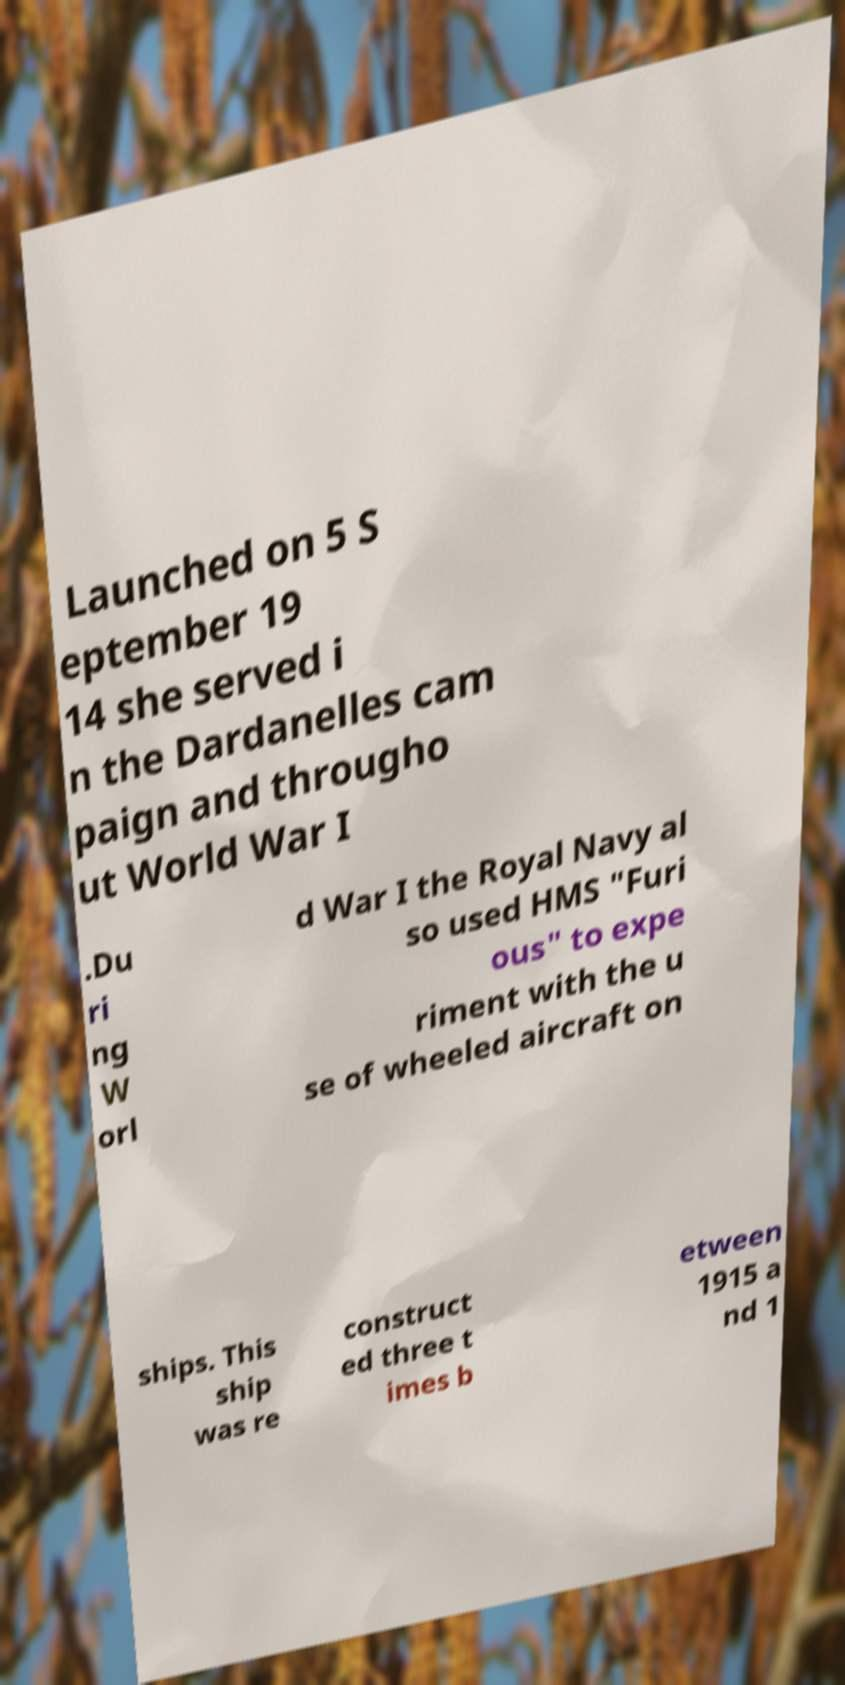Please read and relay the text visible in this image. What does it say? Launched on 5 S eptember 19 14 she served i n the Dardanelles cam paign and througho ut World War I .Du ri ng W orl d War I the Royal Navy al so used HMS "Furi ous" to expe riment with the u se of wheeled aircraft on ships. This ship was re construct ed three t imes b etween 1915 a nd 1 